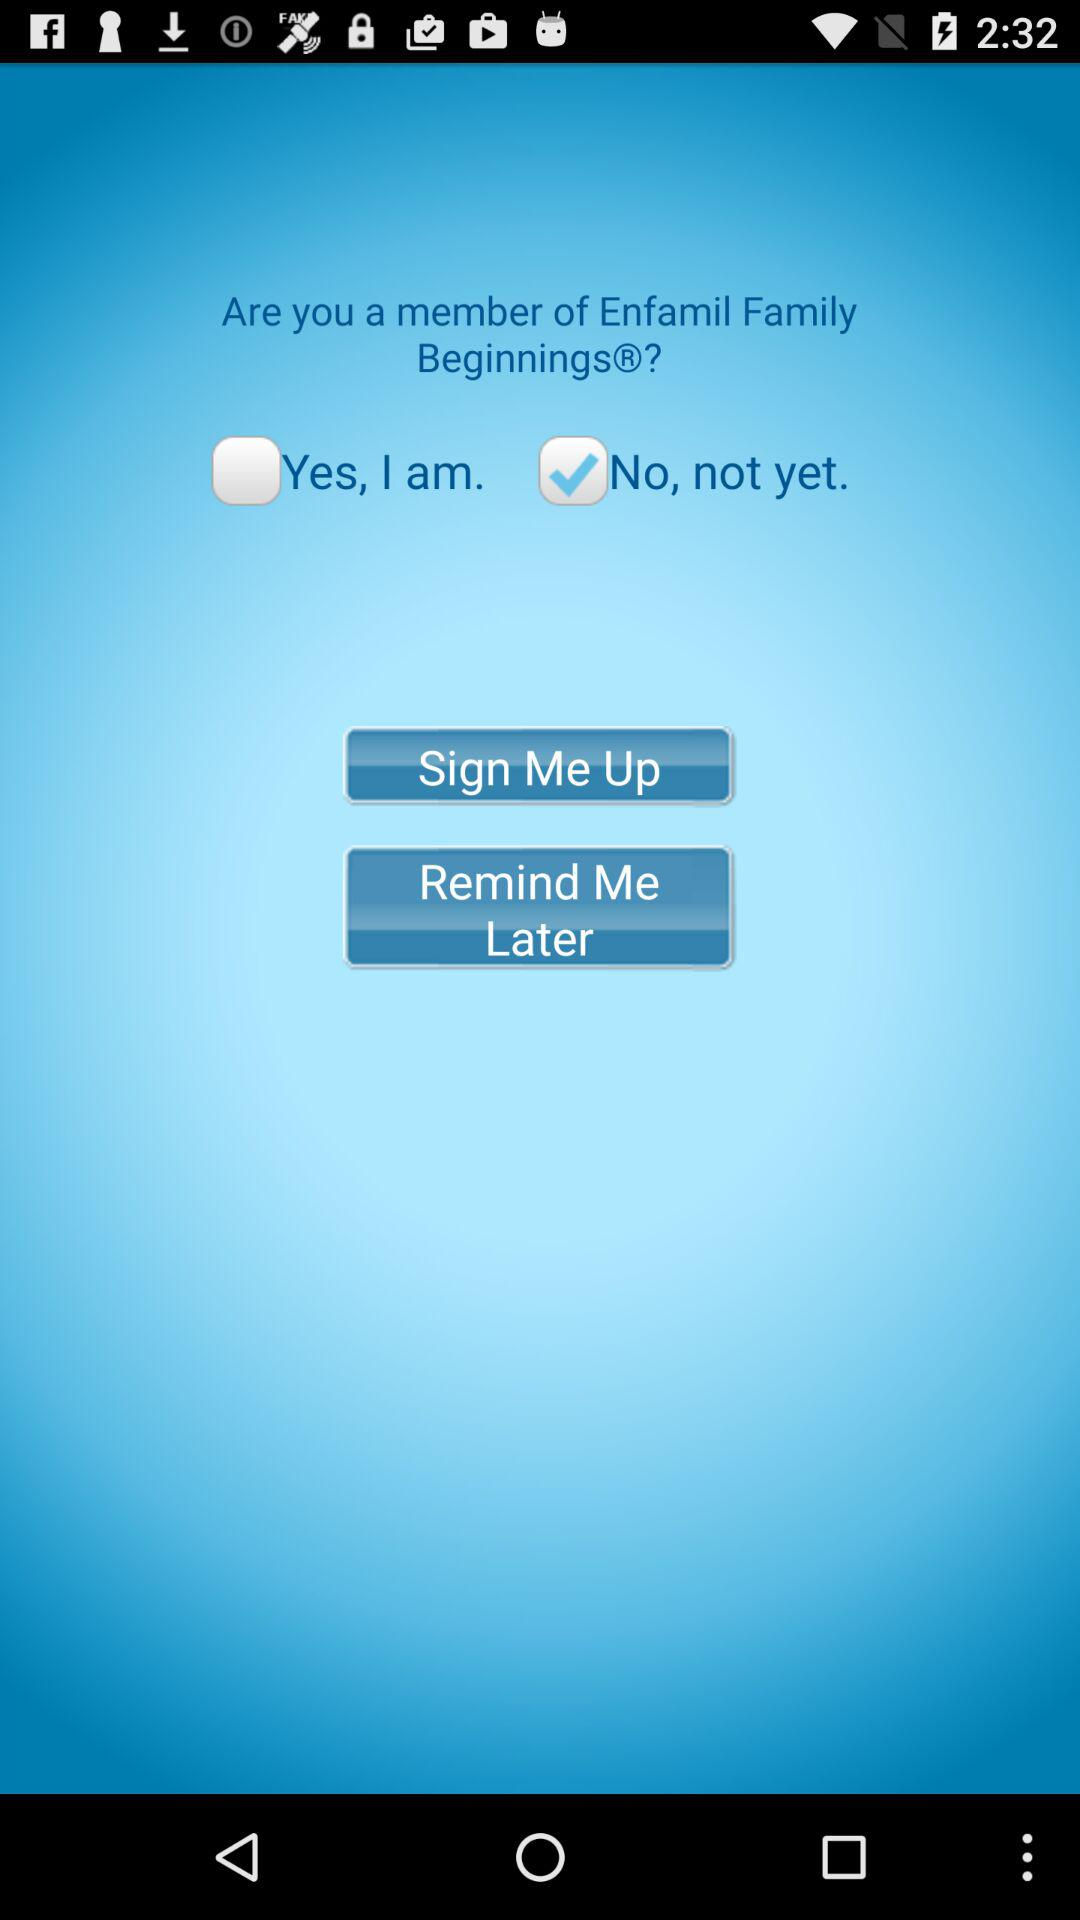What is the status of the "Yes, I am."? The status is "off". 